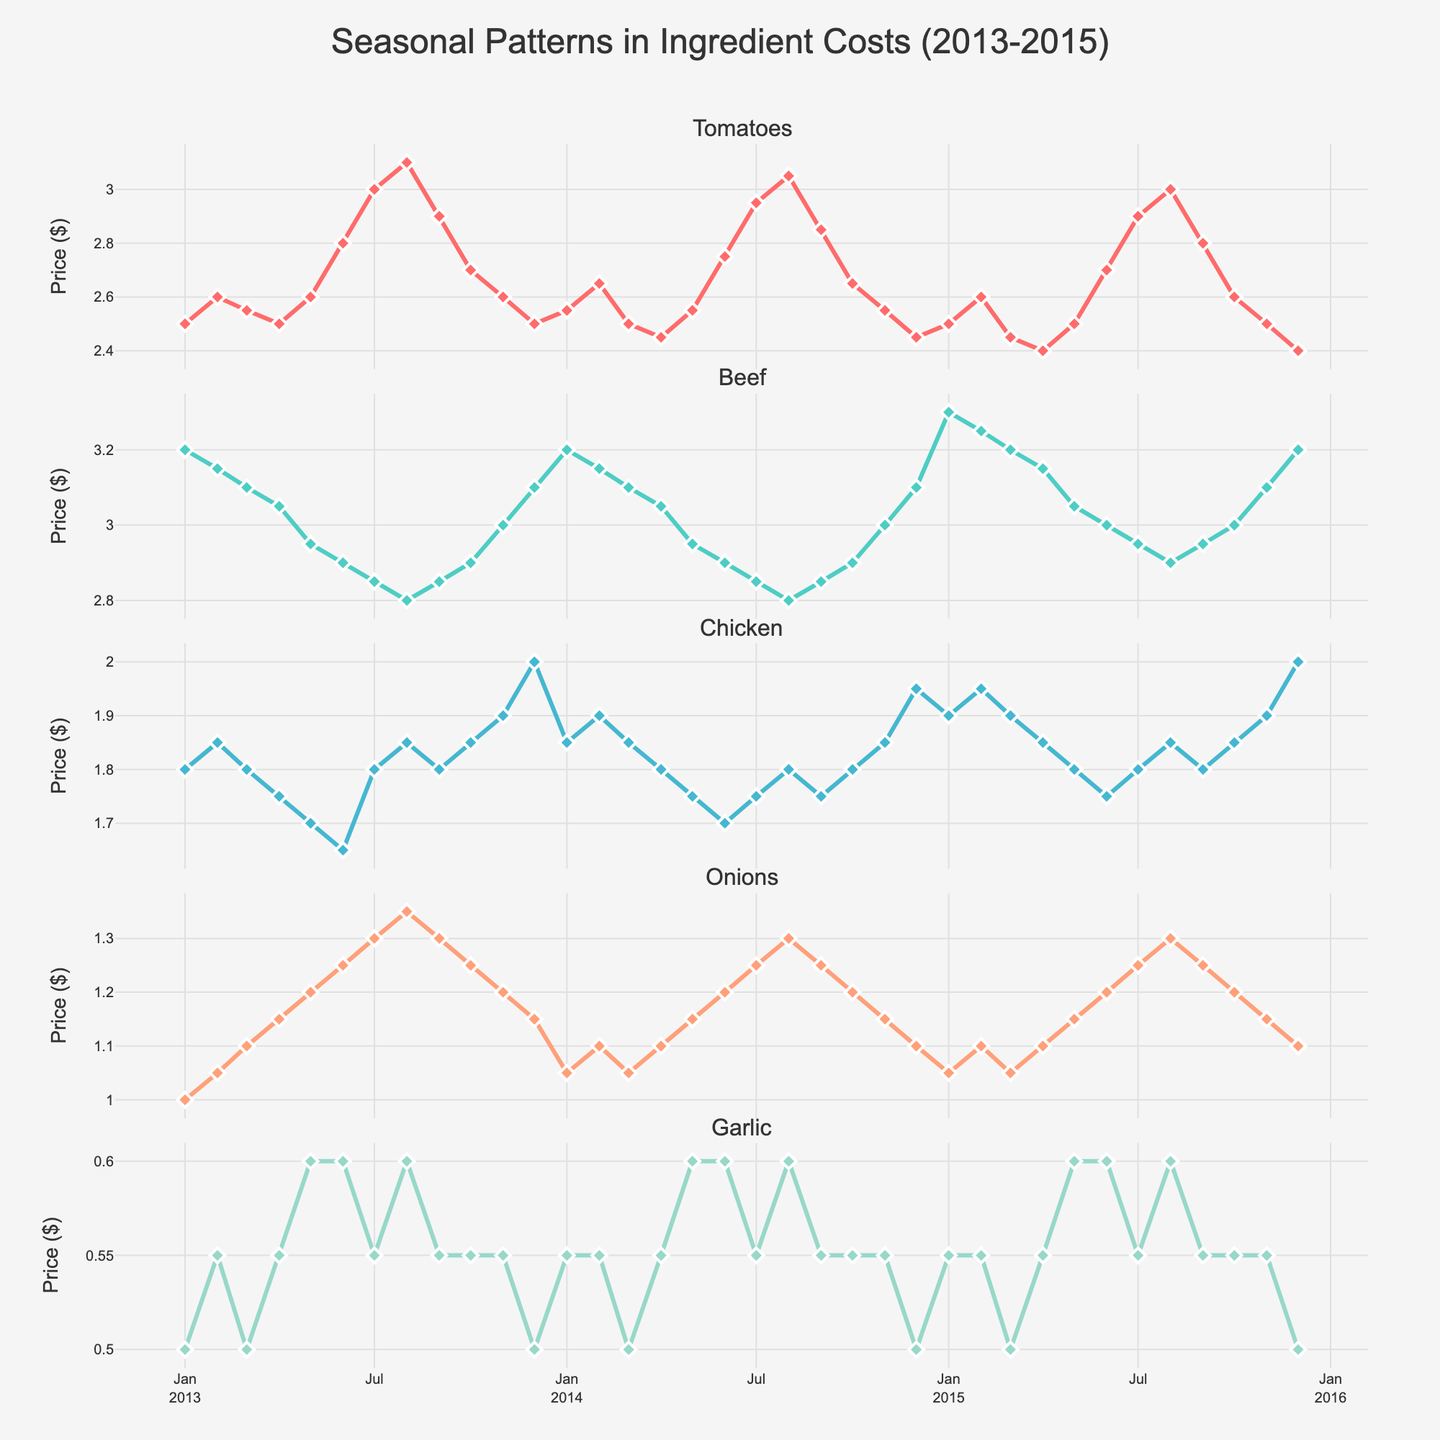What is the title of the plot? The title of the plot can be found at the top center of the figure. It reads "Seasonal Patterns in Ingredient Costs (2013-2015)".
Answer: Seasonal Patterns in Ingredient Costs (2013-2015) How many subplots are in the figure? The figure has different rows for each ingredient, so the number of subplots equals the number of ingredients. There are 5 ingredients being tracked.
Answer: 5 What is the price of Tomatoes in January 2013? Look at the subplot for Tomatoes and find the marker corresponding to January 2013. The y-axis shows the price, which is $2.50.
Answer: $2.50 Which ingredient had the highest price in December 2015? Check the price values for all ingredients in December 2015 across the respective subplots. Beef has the highest price at $3.20.
Answer: Beef Which month generally shows the highest prices for Tomatoes within a given year? Observe the seasonal trends in the Tomato subplot, noting peak points within each year. August consistently shows higher prices for Tomatoes each year.
Answer: August What is the average price of Beef over the entire period? Add up all Beef prices from January 2013 to December 2015 and divide by the total number of months (36). The sum is (3.20+3.15+3.10+3.05+2.95+2.90+2.85+2.80+2.85+2.90+3.00+3.10+3.20+3.15+3.10+3.05+2.95+2.90+2.85+2.80+2.85+2.90+3.00+3.10+3.30+3.25+3.20+3.15+3.05+3.00+2.95+2.90+2.95+3.00+3.10+3.20). The average price is sum/36.
Answer: $3.00 Compare the price trends of Chicken and Onions over the years. Which one is generally more stable? Examine the fluctuations in the Chicken and Onion subplots. Onions show fewer drastic price changes than Chicken, indicating more stability.
Answer: Onions What is the difference between the highest and lowest price of Garlic observed in the data? Identify the highest and lowest prices of Garlic from January 2013 to December 2015 (highest $0.60, lowest $0.50). The difference is 0.60 - 0.50.
Answer: $0.10 